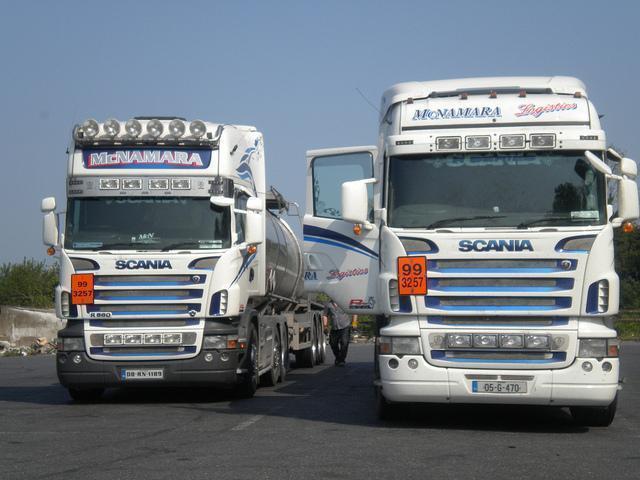What business are these vehicles in?
Choose the correct response and explain in the format: 'Answer: answer
Rationale: rationale.'
Options: Movers, tourism, logistics, gas transportation. Answer: logistics.
Rationale: Logistics is printed on the vehicles. 